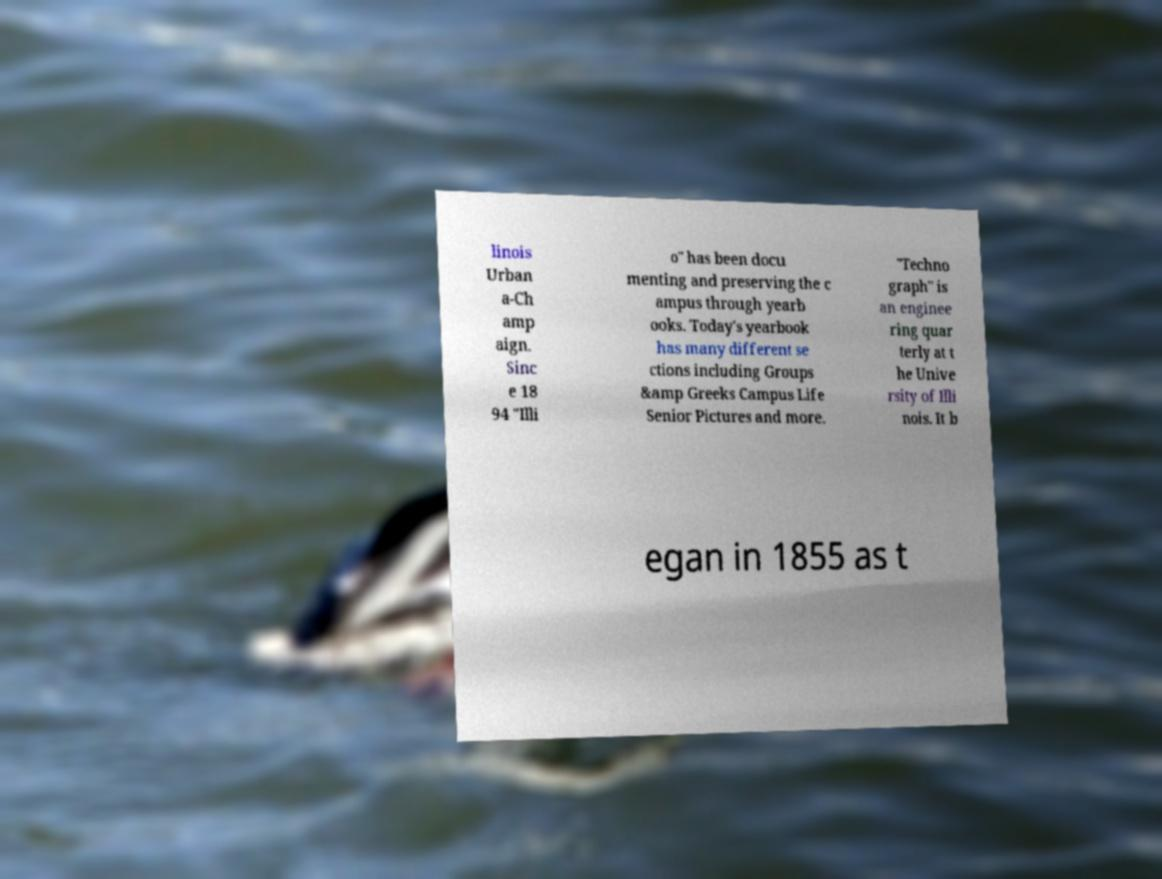What messages or text are displayed in this image? I need them in a readable, typed format. linois Urban a-Ch amp aign. Sinc e 18 94 "Illi o" has been docu menting and preserving the c ampus through yearb ooks. Today's yearbook has many different se ctions including Groups &amp Greeks Campus Life Senior Pictures and more. "Techno graph" is an enginee ring quar terly at t he Unive rsity of Illi nois. It b egan in 1855 as t 